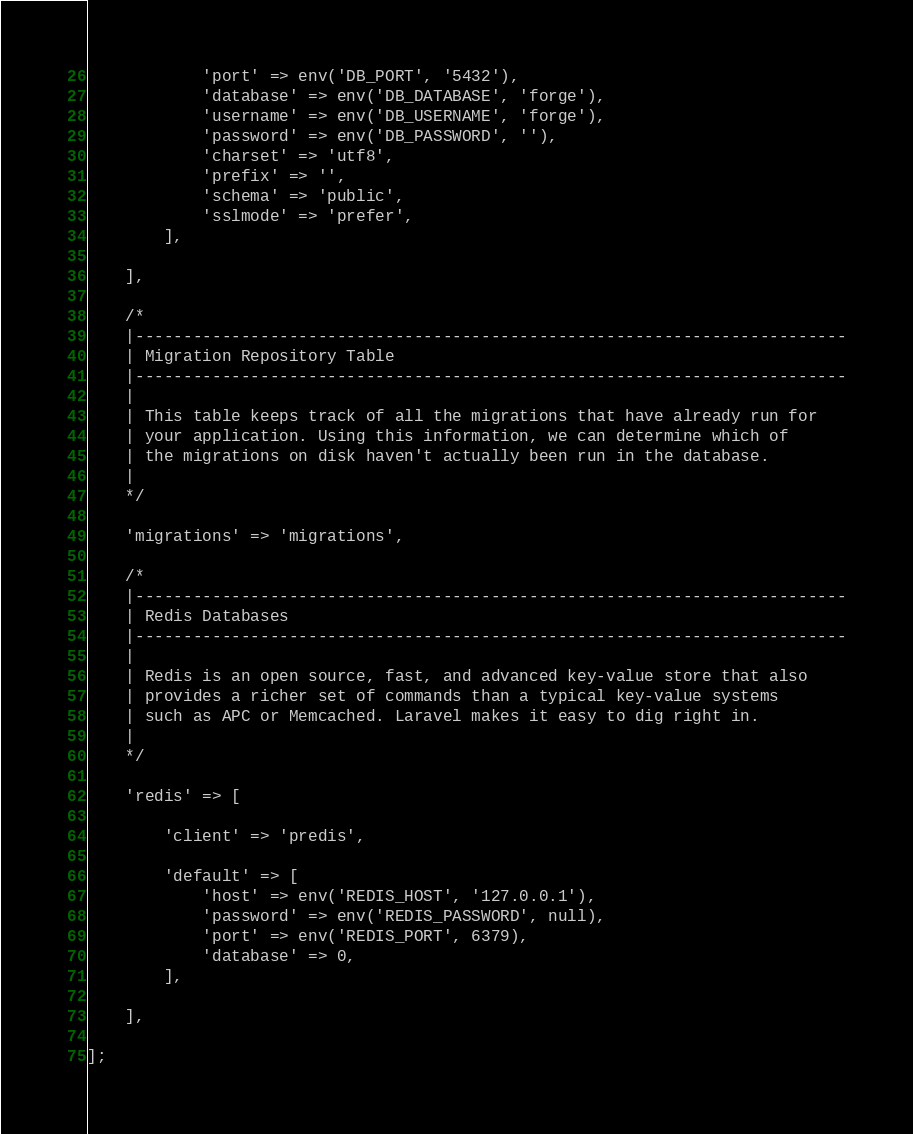Convert code to text. <code><loc_0><loc_0><loc_500><loc_500><_PHP_>            'port' => env('DB_PORT', '5432'),
            'database' => env('DB_DATABASE', 'forge'),
            'username' => env('DB_USERNAME', 'forge'),
            'password' => env('DB_PASSWORD', ''),
            'charset' => 'utf8',
            'prefix' => '',
            'schema' => 'public',
            'sslmode' => 'prefer',
        ],

    ],

    /*
    |--------------------------------------------------------------------------
    | Migration Repository Table
    |--------------------------------------------------------------------------
    |
    | This table keeps track of all the migrations that have already run for
    | your application. Using this information, we can determine which of
    | the migrations on disk haven't actually been run in the database.
    |
    */

    'migrations' => 'migrations',

    /*
    |--------------------------------------------------------------------------
    | Redis Databases
    |--------------------------------------------------------------------------
    |
    | Redis is an open source, fast, and advanced key-value store that also
    | provides a richer set of commands than a typical key-value systems
    | such as APC or Memcached. Laravel makes it easy to dig right in.
    |
    */

    'redis' => [

        'client' => 'predis',

        'default' => [
            'host' => env('REDIS_HOST', '127.0.0.1'),
            'password' => env('REDIS_PASSWORD', null),
            'port' => env('REDIS_PORT', 6379),
            'database' => 0,
        ],

    ],

];
</code> 